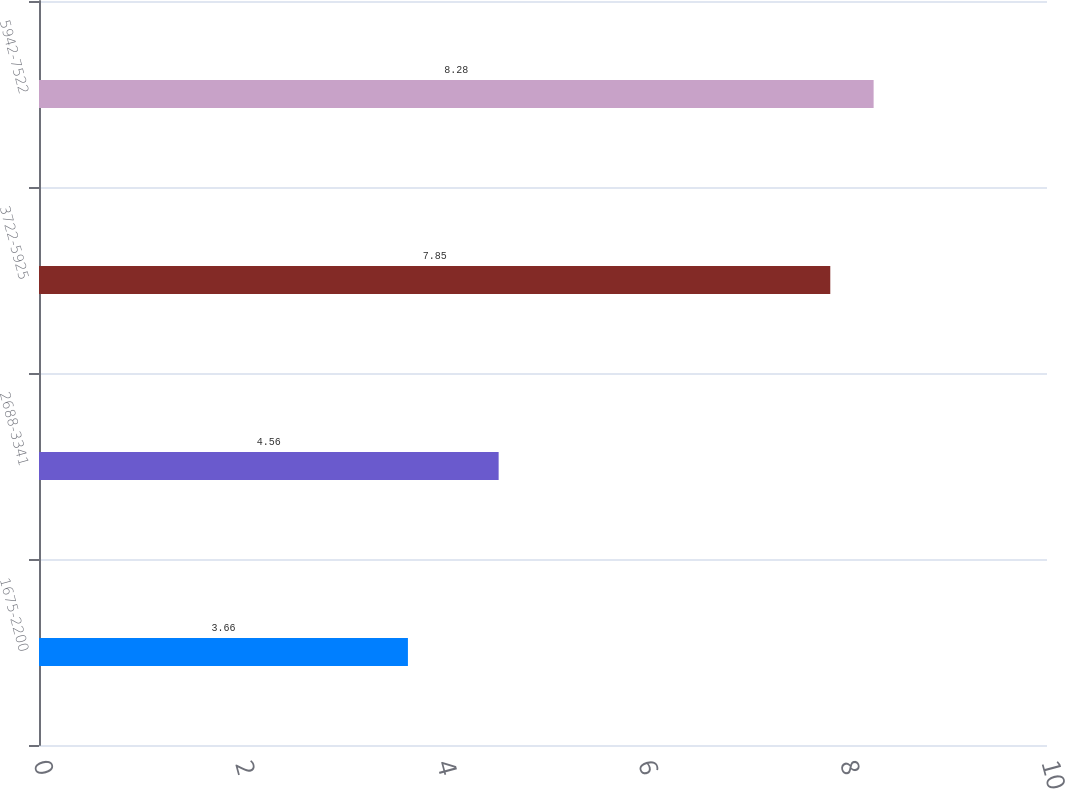Convert chart to OTSL. <chart><loc_0><loc_0><loc_500><loc_500><bar_chart><fcel>1675-2200<fcel>2688-3341<fcel>3722-5925<fcel>5942-7522<nl><fcel>3.66<fcel>4.56<fcel>7.85<fcel>8.28<nl></chart> 